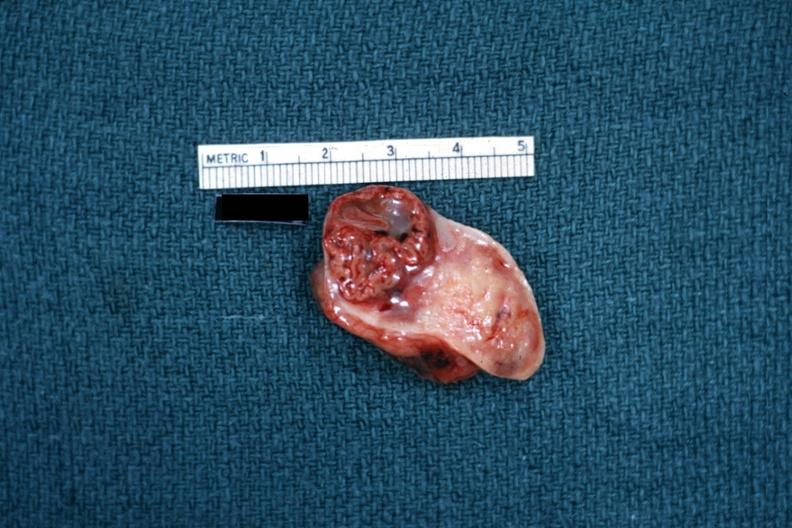s ovary present?
Answer the question using a single word or phrase. Yes 